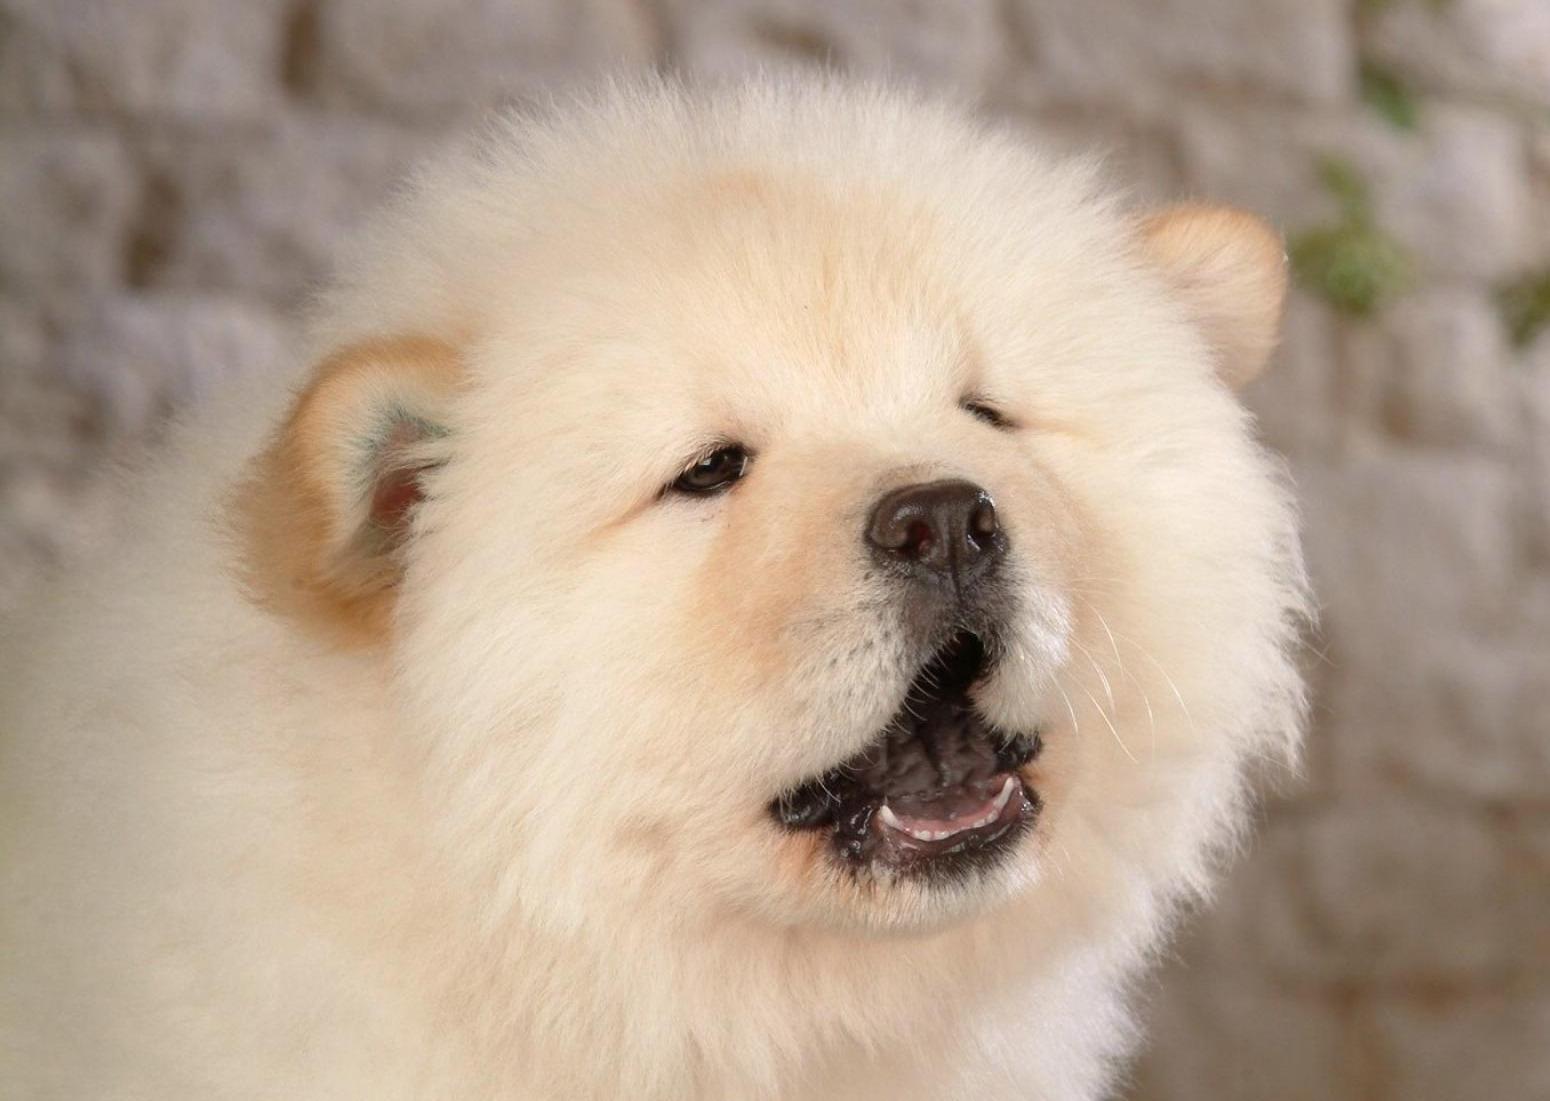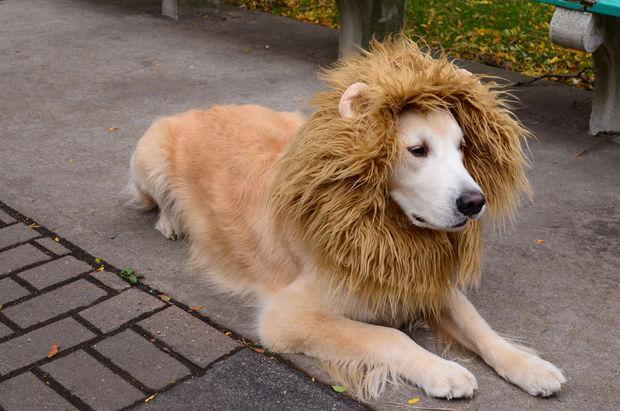The first image is the image on the left, the second image is the image on the right. Examine the images to the left and right. Is the description "The left and right image contains the same number of dogs with at least one laying down." accurate? Answer yes or no. Yes. The first image is the image on the left, the second image is the image on the right. Considering the images on both sides, is "The combined images include two chows and one other animal figure, all are the same color, and at least two have their paws forward." valid? Answer yes or no. No. 